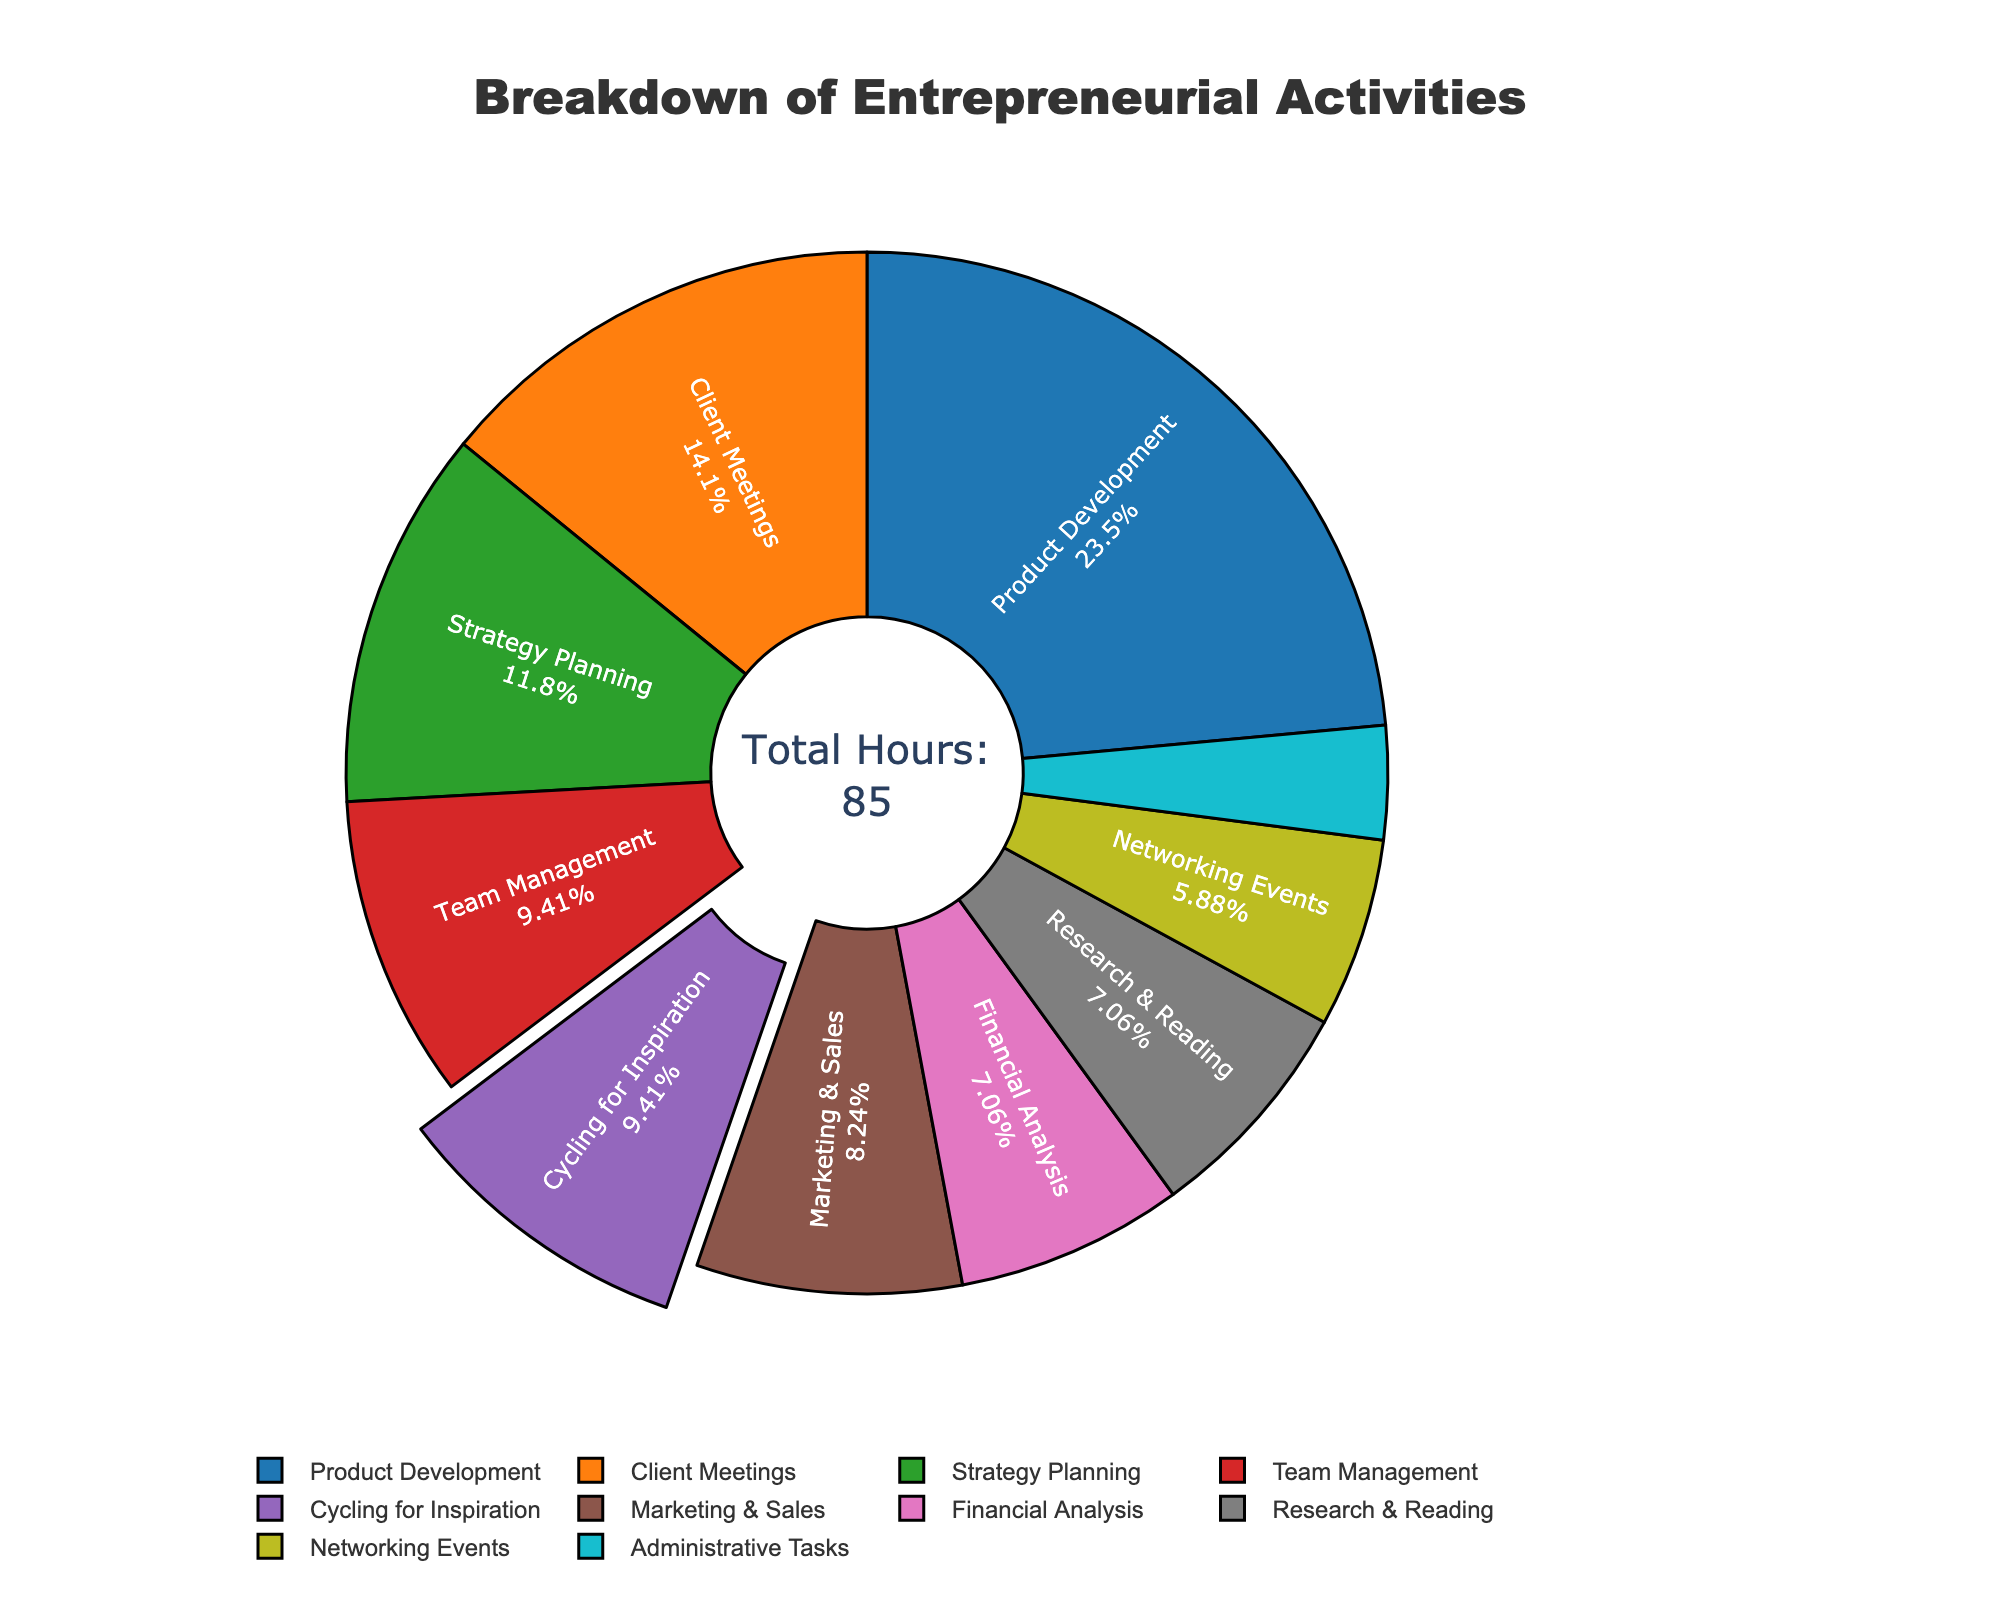What percentage of time is spent on Product Development? Product Development takes up 20 hours of the total 85 hours. To find the percentage: (20/85) * 100 = 23.5%.
Answer: 23.5% Which activity consumes more hours, Strategy Planning or Financial Analysis? Strategy Planning consumes 10 hours, while Financial Analysis consumes 6 hours. Since 10 > 6, Strategy Planning consumes more hours.
Answer: Strategy Planning What's the total percentage of time spent on Cycling for Inspiration and Team Management combined? Cycling for Inspiration accounts for 8 hours and Team Management also accounts for 8 hours. Combined, they take 16 hours. To find the percentage: (16/85) * 100 = 18.8%.
Answer: 18.8% Is more time spent on Client Meetings or Marketing & Sales? Client Meetings consume 12 hours, while Marketing & Sales consume 7 hours. Since 12 > 7, more time is spent on Client Meetings.
Answer: Client Meetings What is the least time-consuming activity? By looking at the pie chart, the smallest section corresponds to Administrative Tasks, which consume 3 hours.
Answer: Administrative Tasks Which activity is highlighted or "pulled out" in the pie chart? The visual impression of the pie chart shows one segment slightly pulled out, which corresponds to Cycling for Inspiration.
Answer: Cycling for Inspiration How much more time is spent on Product Development compared to Networking Events? Product Development consumes 20 hours, while Networking Events consume 5 hours. The difference is 20 - 5 = 15 hours.
Answer: 15 hours What activities, other than Product Development, take up more than 10% of the total time? To find activities taking more than 10% of 85 hours (> 8.5 hours), we see that Client Meetings (12 hours, 14.1%) and Strategy Planning (10 hours, 11.8%) meet this criterion.
Answer: Client Meetings, Strategy Planning What is the combined time spent on Research & Reading and Financial Analysis? Research & Reading consumes 6 hours and Financial Analysis also consumes 6 hours. Combined, they take 6 + 6 = 12 hours.
Answer: 12 hours Which activities are under 10% of total time each? Activities under 10% of 85 hours (< 8.5 hours) are: Team Management (8 hours, 9.4%), Marketing & Sales (7 hours, 8.2%), Financial Analysis (6 hours, 7.1%), Networking Events (5 hours, 5.9%), Research & Reading (6 hours, 7.1%), and Administrative Tasks (3 hours, 3.5%).
Answer: Team Management, Marketing & Sales, Financial Analysis, Networking Events, Research & Reading, Administrative Tasks 